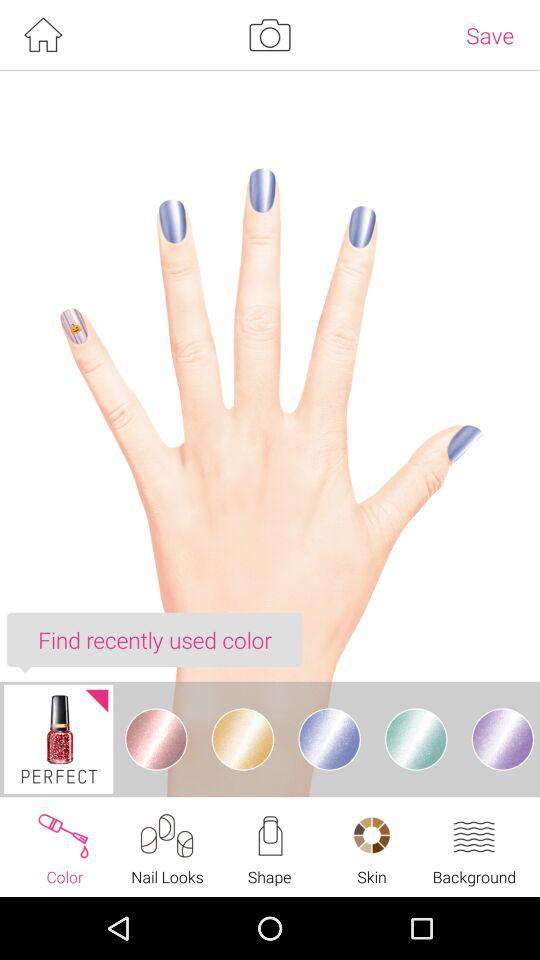Which is the selected tab? The selected tab is "Color". 